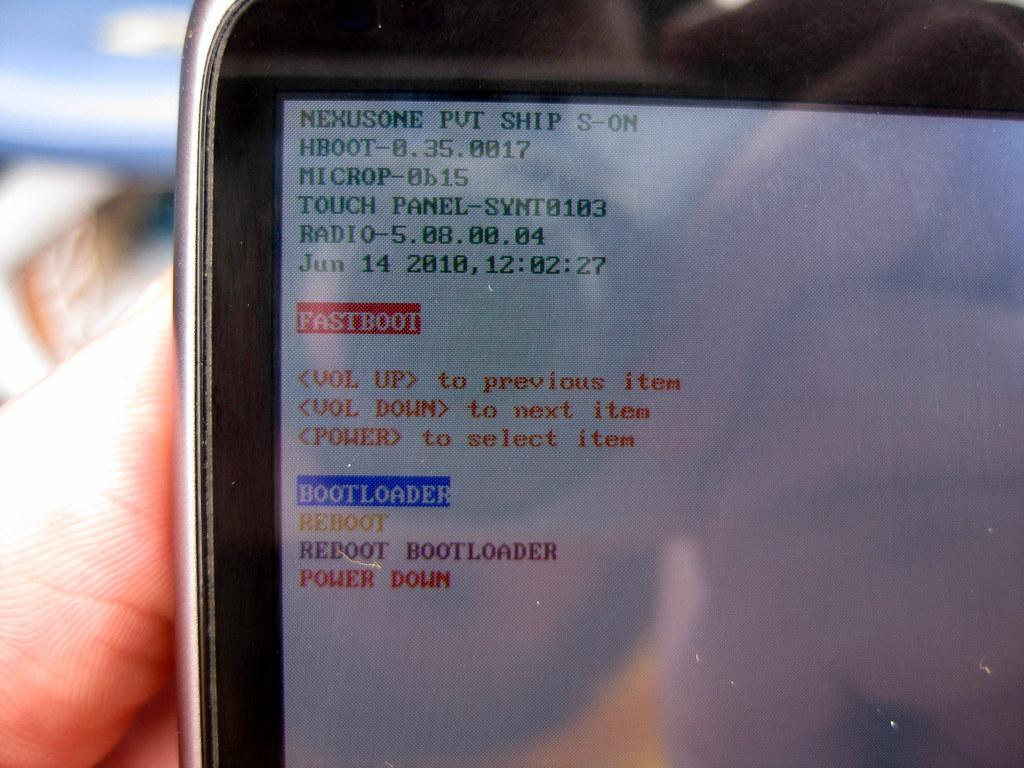<image>
Give a short and clear explanation of the subsequent image. A screen displays green text with the first word as nexusome. 